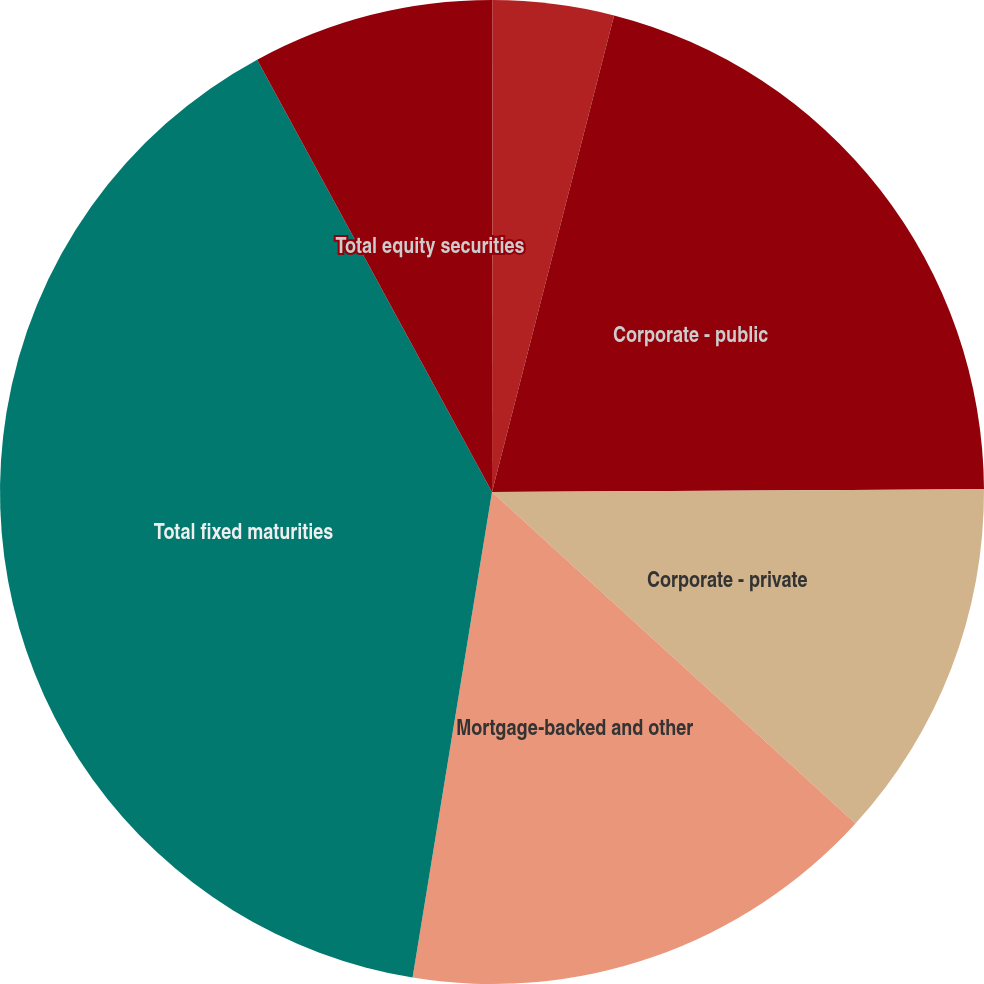<chart> <loc_0><loc_0><loc_500><loc_500><pie_chart><fcel>Non-US governments<fcel>States and political<fcel>Corporate - public<fcel>Corporate - private<fcel>Mortgage-backed and other<fcel>Total fixed maturities<fcel>Total equity securities<nl><fcel>0.02%<fcel>3.97%<fcel>20.92%<fcel>11.86%<fcel>15.81%<fcel>39.5%<fcel>7.92%<nl></chart> 